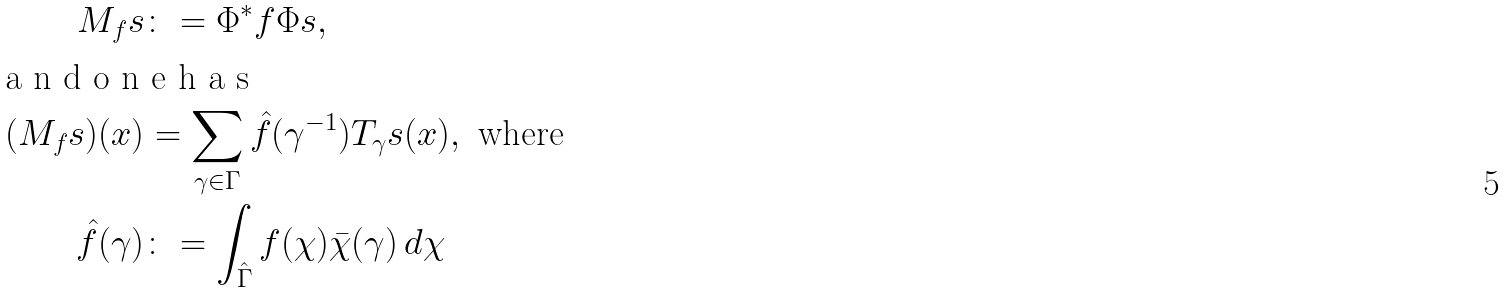<formula> <loc_0><loc_0><loc_500><loc_500>M _ { f } s & \colon = \Phi ^ { * } f \Phi s , \\ \intertext { a n d o n e h a s } ( M _ { f } s ) ( x ) & = \sum _ { \gamma \in \Gamma } \hat { f } ( \gamma ^ { - 1 } ) T _ { \gamma } s ( x ) , \text { where} \\ \hat { f } ( \gamma ) & \colon = \int _ { \hat { \Gamma } } f ( \chi ) \bar { \chi } ( \gamma ) \, d \chi</formula> 